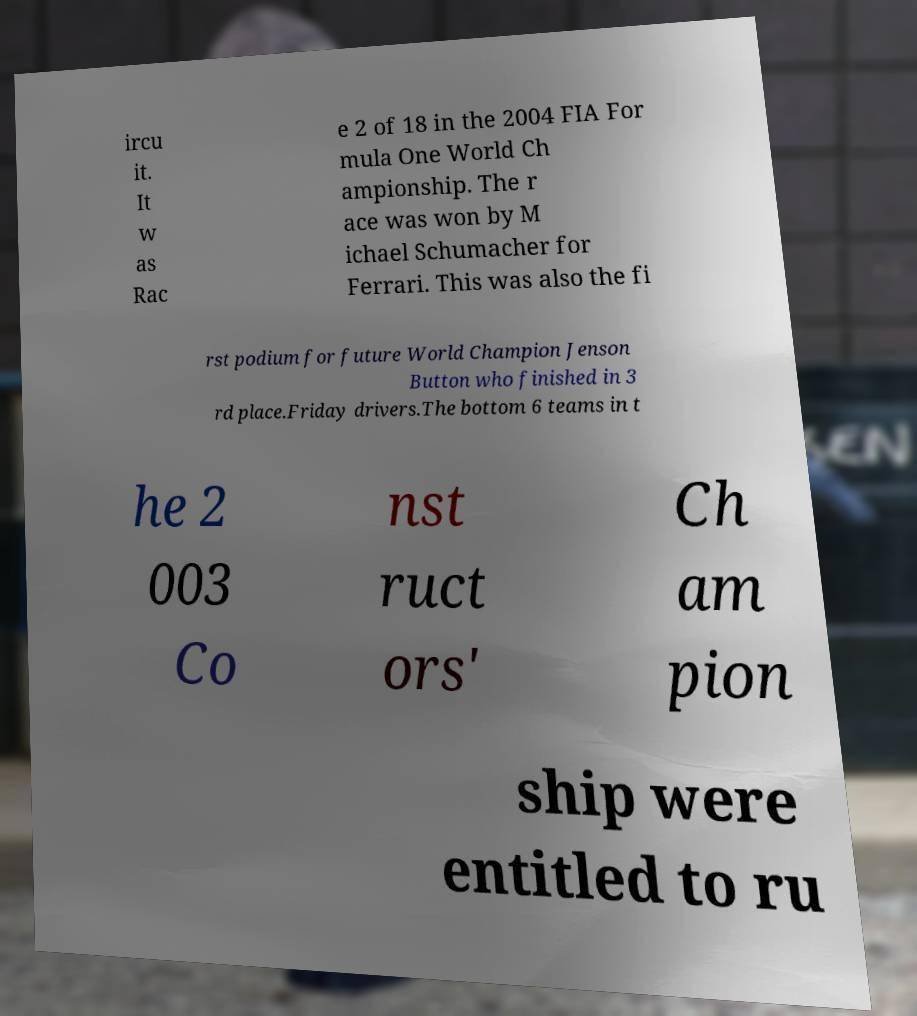Please read and relay the text visible in this image. What does it say? ircu it. It w as Rac e 2 of 18 in the 2004 FIA For mula One World Ch ampionship. The r ace was won by M ichael Schumacher for Ferrari. This was also the fi rst podium for future World Champion Jenson Button who finished in 3 rd place.Friday drivers.The bottom 6 teams in t he 2 003 Co nst ruct ors' Ch am pion ship were entitled to ru 